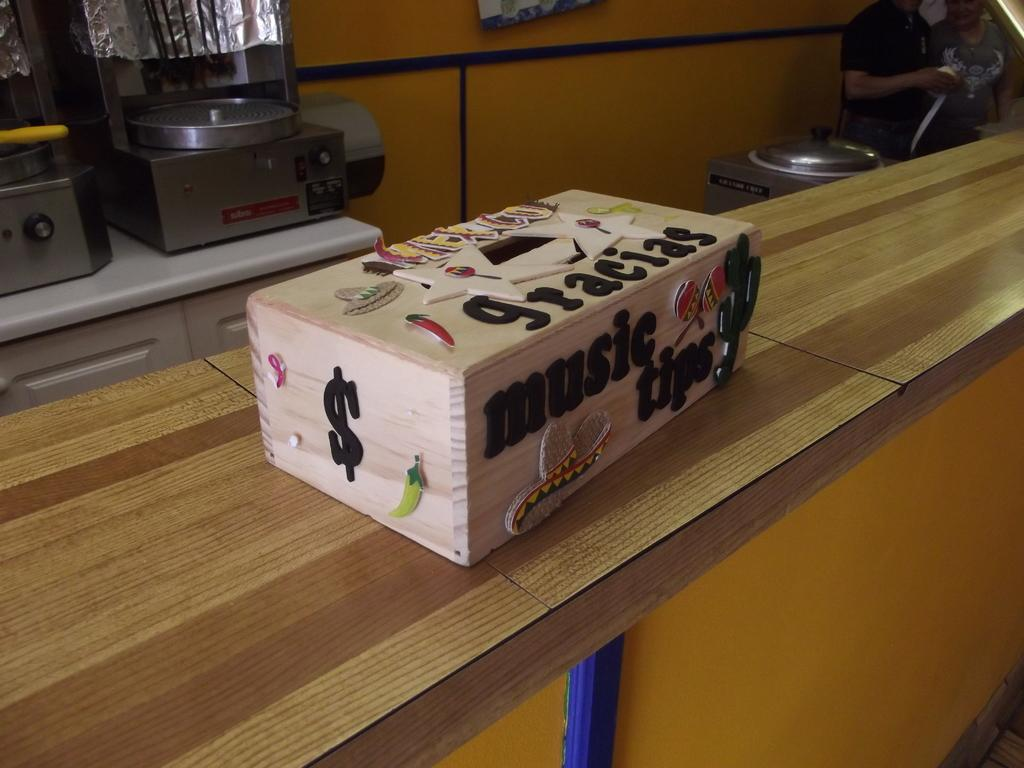<image>
Describe the image concisely. A music tips box sitting on a counter in a kitchen. 